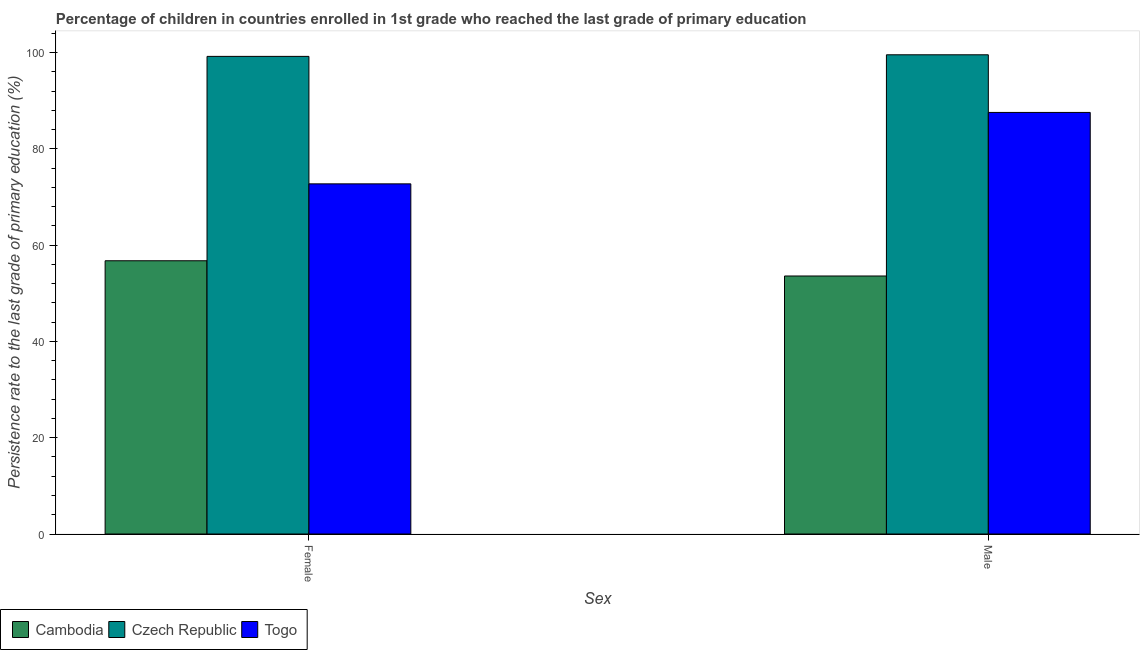How many different coloured bars are there?
Give a very brief answer. 3. How many groups of bars are there?
Offer a terse response. 2. Are the number of bars on each tick of the X-axis equal?
Provide a succinct answer. Yes. How many bars are there on the 1st tick from the right?
Keep it short and to the point. 3. What is the label of the 2nd group of bars from the left?
Offer a terse response. Male. What is the persistence rate of female students in Czech Republic?
Offer a very short reply. 99.2. Across all countries, what is the maximum persistence rate of female students?
Your response must be concise. 99.2. Across all countries, what is the minimum persistence rate of female students?
Offer a very short reply. 56.75. In which country was the persistence rate of female students maximum?
Give a very brief answer. Czech Republic. In which country was the persistence rate of female students minimum?
Offer a very short reply. Cambodia. What is the total persistence rate of female students in the graph?
Your response must be concise. 228.68. What is the difference between the persistence rate of male students in Togo and that in Czech Republic?
Give a very brief answer. -11.97. What is the difference between the persistence rate of female students in Togo and the persistence rate of male students in Czech Republic?
Keep it short and to the point. -26.81. What is the average persistence rate of female students per country?
Give a very brief answer. 76.23. What is the difference between the persistence rate of male students and persistence rate of female students in Togo?
Offer a very short reply. 14.84. What is the ratio of the persistence rate of male students in Czech Republic to that in Cambodia?
Provide a succinct answer. 1.86. What does the 3rd bar from the left in Female represents?
Provide a short and direct response. Togo. What does the 2nd bar from the right in Male represents?
Keep it short and to the point. Czech Republic. How many bars are there?
Offer a terse response. 6. How many countries are there in the graph?
Keep it short and to the point. 3. Does the graph contain any zero values?
Ensure brevity in your answer.  No. Does the graph contain grids?
Your response must be concise. No. How many legend labels are there?
Offer a terse response. 3. How are the legend labels stacked?
Provide a succinct answer. Horizontal. What is the title of the graph?
Provide a succinct answer. Percentage of children in countries enrolled in 1st grade who reached the last grade of primary education. What is the label or title of the X-axis?
Provide a succinct answer. Sex. What is the label or title of the Y-axis?
Your answer should be compact. Persistence rate to the last grade of primary education (%). What is the Persistence rate to the last grade of primary education (%) of Cambodia in Female?
Provide a succinct answer. 56.75. What is the Persistence rate to the last grade of primary education (%) of Czech Republic in Female?
Provide a succinct answer. 99.2. What is the Persistence rate to the last grade of primary education (%) of Togo in Female?
Your response must be concise. 72.73. What is the Persistence rate to the last grade of primary education (%) in Cambodia in Male?
Your answer should be very brief. 53.59. What is the Persistence rate to the last grade of primary education (%) in Czech Republic in Male?
Offer a very short reply. 99.53. What is the Persistence rate to the last grade of primary education (%) of Togo in Male?
Ensure brevity in your answer.  87.56. Across all Sex, what is the maximum Persistence rate to the last grade of primary education (%) in Cambodia?
Your answer should be compact. 56.75. Across all Sex, what is the maximum Persistence rate to the last grade of primary education (%) of Czech Republic?
Give a very brief answer. 99.53. Across all Sex, what is the maximum Persistence rate to the last grade of primary education (%) in Togo?
Offer a very short reply. 87.56. Across all Sex, what is the minimum Persistence rate to the last grade of primary education (%) in Cambodia?
Provide a short and direct response. 53.59. Across all Sex, what is the minimum Persistence rate to the last grade of primary education (%) of Czech Republic?
Make the answer very short. 99.2. Across all Sex, what is the minimum Persistence rate to the last grade of primary education (%) of Togo?
Your response must be concise. 72.73. What is the total Persistence rate to the last grade of primary education (%) in Cambodia in the graph?
Ensure brevity in your answer.  110.34. What is the total Persistence rate to the last grade of primary education (%) in Czech Republic in the graph?
Ensure brevity in your answer.  198.73. What is the total Persistence rate to the last grade of primary education (%) in Togo in the graph?
Ensure brevity in your answer.  160.29. What is the difference between the Persistence rate to the last grade of primary education (%) in Cambodia in Female and that in Male?
Provide a short and direct response. 3.17. What is the difference between the Persistence rate to the last grade of primary education (%) in Czech Republic in Female and that in Male?
Offer a very short reply. -0.33. What is the difference between the Persistence rate to the last grade of primary education (%) in Togo in Female and that in Male?
Ensure brevity in your answer.  -14.84. What is the difference between the Persistence rate to the last grade of primary education (%) in Cambodia in Female and the Persistence rate to the last grade of primary education (%) in Czech Republic in Male?
Your response must be concise. -42.78. What is the difference between the Persistence rate to the last grade of primary education (%) in Cambodia in Female and the Persistence rate to the last grade of primary education (%) in Togo in Male?
Ensure brevity in your answer.  -30.81. What is the difference between the Persistence rate to the last grade of primary education (%) in Czech Republic in Female and the Persistence rate to the last grade of primary education (%) in Togo in Male?
Provide a short and direct response. 11.64. What is the average Persistence rate to the last grade of primary education (%) in Cambodia per Sex?
Your answer should be very brief. 55.17. What is the average Persistence rate to the last grade of primary education (%) of Czech Republic per Sex?
Your answer should be compact. 99.37. What is the average Persistence rate to the last grade of primary education (%) in Togo per Sex?
Your answer should be compact. 80.14. What is the difference between the Persistence rate to the last grade of primary education (%) in Cambodia and Persistence rate to the last grade of primary education (%) in Czech Republic in Female?
Give a very brief answer. -42.45. What is the difference between the Persistence rate to the last grade of primary education (%) of Cambodia and Persistence rate to the last grade of primary education (%) of Togo in Female?
Offer a very short reply. -15.97. What is the difference between the Persistence rate to the last grade of primary education (%) in Czech Republic and Persistence rate to the last grade of primary education (%) in Togo in Female?
Provide a short and direct response. 26.47. What is the difference between the Persistence rate to the last grade of primary education (%) of Cambodia and Persistence rate to the last grade of primary education (%) of Czech Republic in Male?
Offer a very short reply. -45.94. What is the difference between the Persistence rate to the last grade of primary education (%) in Cambodia and Persistence rate to the last grade of primary education (%) in Togo in Male?
Your answer should be very brief. -33.97. What is the difference between the Persistence rate to the last grade of primary education (%) in Czech Republic and Persistence rate to the last grade of primary education (%) in Togo in Male?
Your answer should be very brief. 11.97. What is the ratio of the Persistence rate to the last grade of primary education (%) of Cambodia in Female to that in Male?
Your answer should be compact. 1.06. What is the ratio of the Persistence rate to the last grade of primary education (%) in Czech Republic in Female to that in Male?
Your answer should be compact. 1. What is the ratio of the Persistence rate to the last grade of primary education (%) in Togo in Female to that in Male?
Keep it short and to the point. 0.83. What is the difference between the highest and the second highest Persistence rate to the last grade of primary education (%) of Cambodia?
Keep it short and to the point. 3.17. What is the difference between the highest and the second highest Persistence rate to the last grade of primary education (%) of Czech Republic?
Your response must be concise. 0.33. What is the difference between the highest and the second highest Persistence rate to the last grade of primary education (%) in Togo?
Ensure brevity in your answer.  14.84. What is the difference between the highest and the lowest Persistence rate to the last grade of primary education (%) of Cambodia?
Provide a short and direct response. 3.17. What is the difference between the highest and the lowest Persistence rate to the last grade of primary education (%) in Czech Republic?
Provide a short and direct response. 0.33. What is the difference between the highest and the lowest Persistence rate to the last grade of primary education (%) of Togo?
Your answer should be compact. 14.84. 